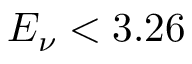Convert formula to latex. <formula><loc_0><loc_0><loc_500><loc_500>E _ { \nu } < 3 . 2 6</formula> 